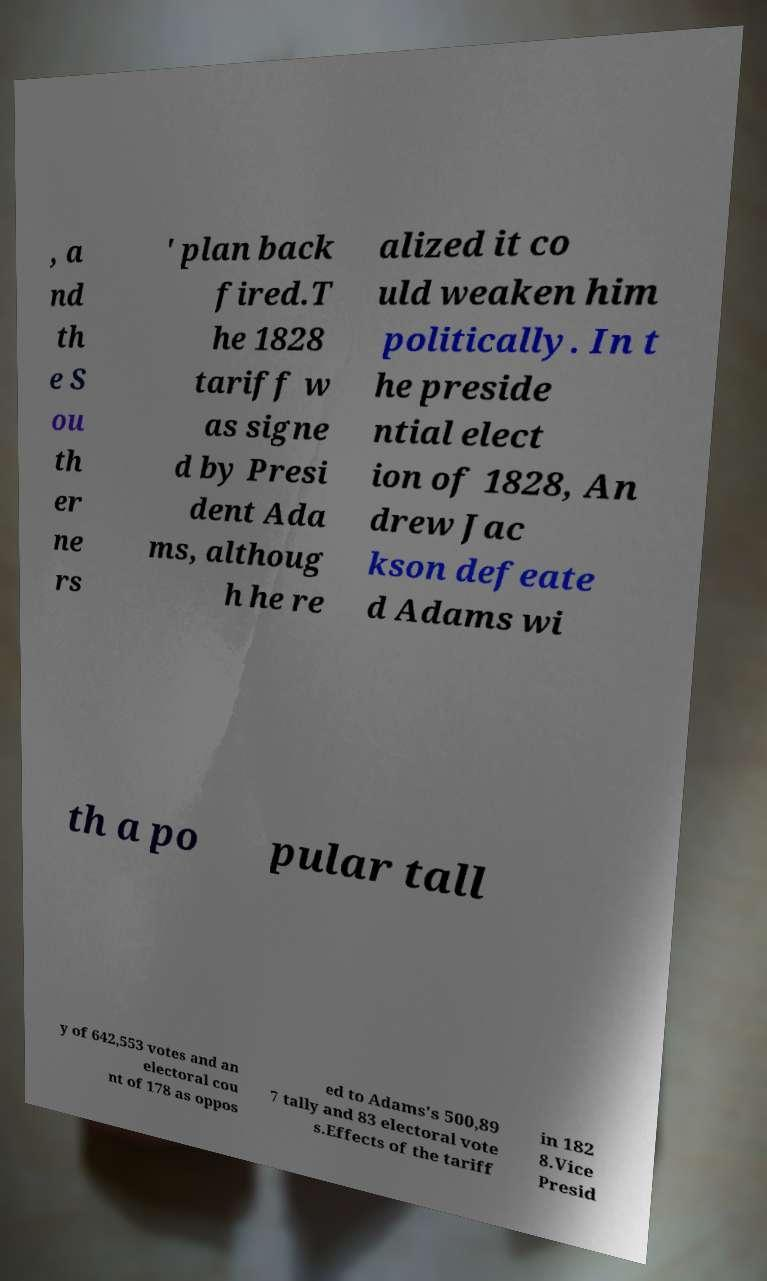I need the written content from this picture converted into text. Can you do that? , a nd th e S ou th er ne rs ' plan back fired.T he 1828 tariff w as signe d by Presi dent Ada ms, althoug h he re alized it co uld weaken him politically. In t he preside ntial elect ion of 1828, An drew Jac kson defeate d Adams wi th a po pular tall y of 642,553 votes and an electoral cou nt of 178 as oppos ed to Adams's 500,89 7 tally and 83 electoral vote s.Effects of the tariff in 182 8.Vice Presid 